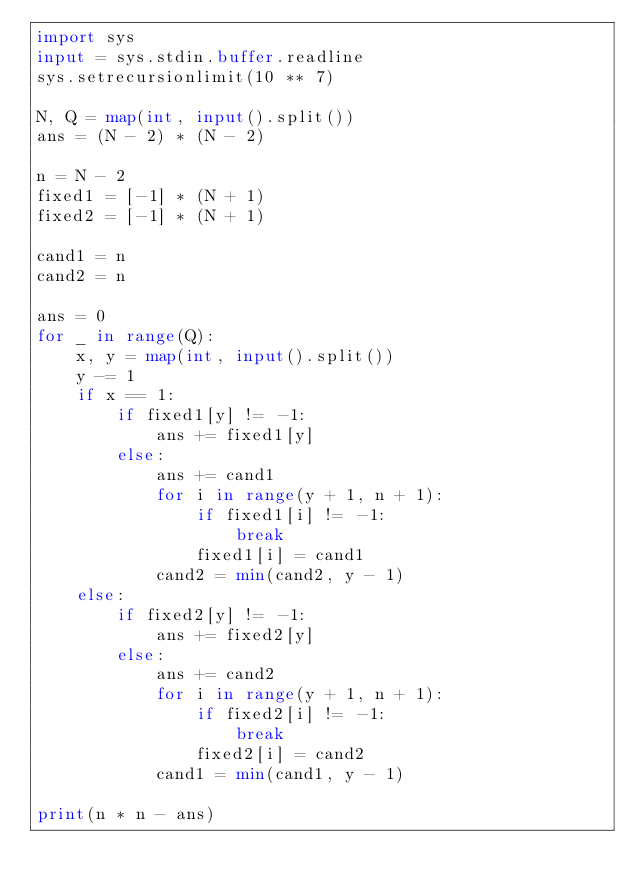Convert code to text. <code><loc_0><loc_0><loc_500><loc_500><_Python_>import sys
input = sys.stdin.buffer.readline
sys.setrecursionlimit(10 ** 7)

N, Q = map(int, input().split())
ans = (N - 2) * (N - 2)

n = N - 2
fixed1 = [-1] * (N + 1)
fixed2 = [-1] * (N + 1)

cand1 = n
cand2 = n

ans = 0
for _ in range(Q):
    x, y = map(int, input().split())
    y -= 1
    if x == 1:
        if fixed1[y] != -1:
            ans += fixed1[y]
        else:
            ans += cand1
            for i in range(y + 1, n + 1):
                if fixed1[i] != -1:
                    break
                fixed1[i] = cand1
            cand2 = min(cand2, y - 1)
    else:
        if fixed2[y] != -1:
            ans += fixed2[y]
        else:
            ans += cand2
            for i in range(y + 1, n + 1):
                if fixed2[i] != -1:
                    break
                fixed2[i] = cand2
            cand1 = min(cand1, y - 1)

print(n * n - ans)</code> 